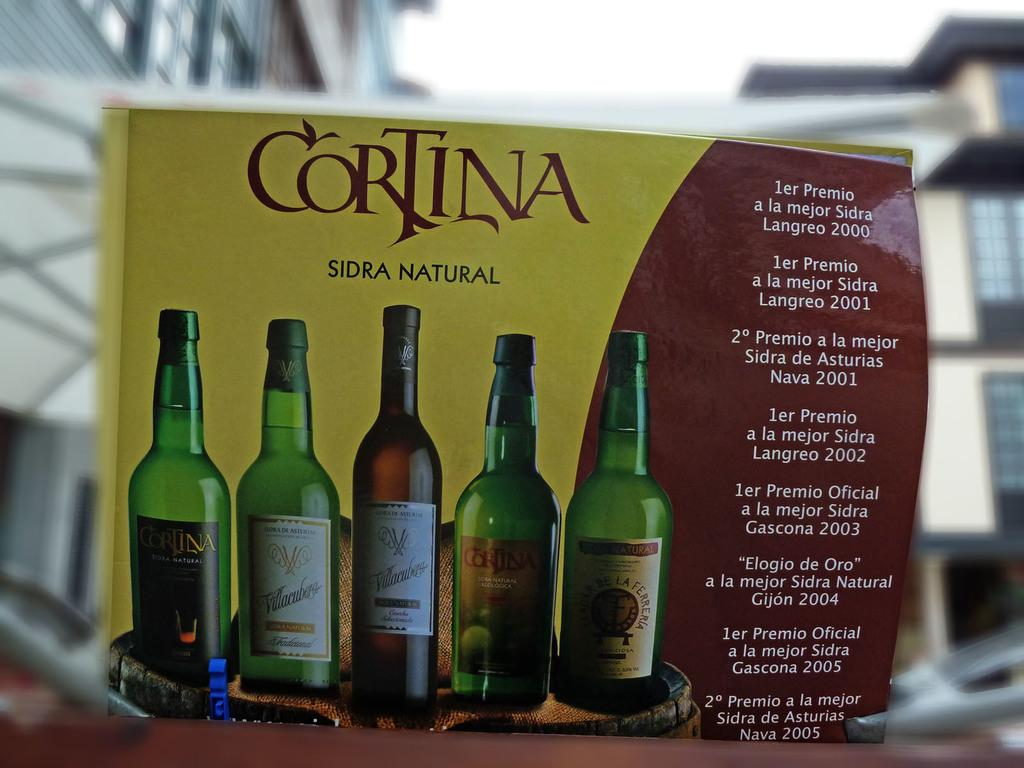<image>
Present a compact description of the photo's key features. A box showing different ciders from Cortina is on a table against a blurred background. 